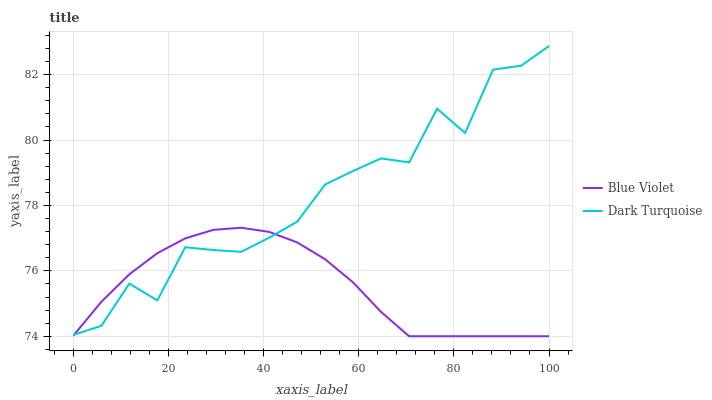Does Blue Violet have the maximum area under the curve?
Answer yes or no. No. Is Blue Violet the roughest?
Answer yes or no. No. Does Blue Violet have the highest value?
Answer yes or no. No. 